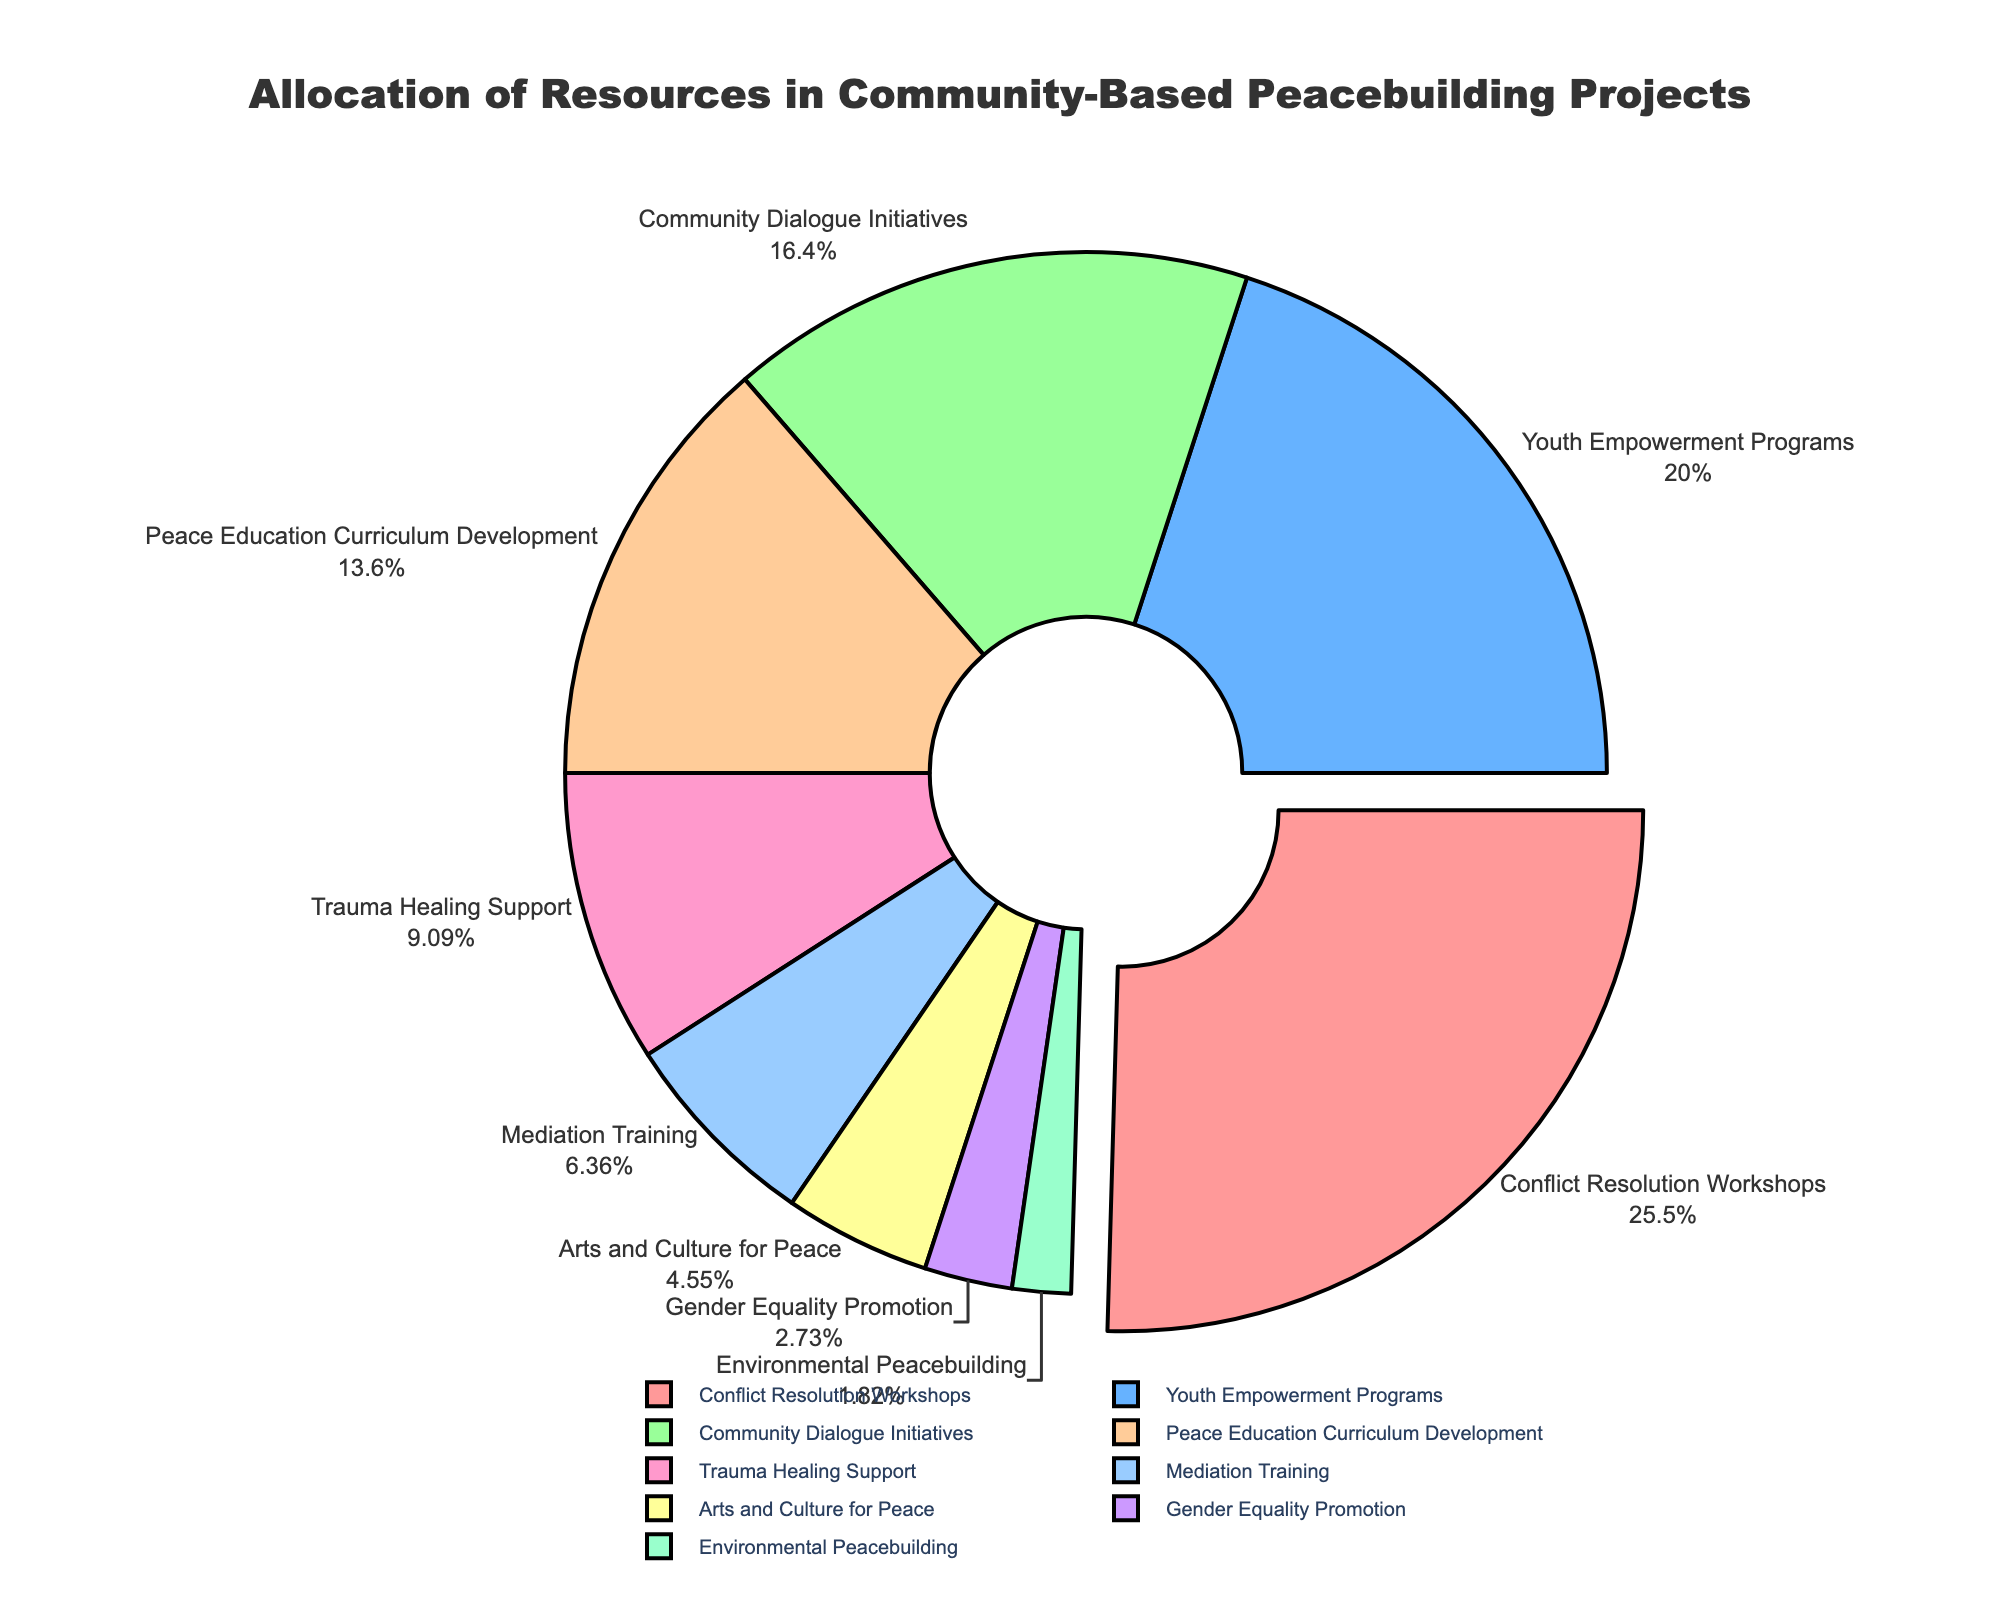Which category receives the highest allocation of resources? The largest portion of the pie chart, which is pulled out slightly, represents the category with the highest allocation of resources. This is "Conflict Resolution Workshops".
Answer: Conflict Resolution Workshops Which category has the smallest allocation of resources? The smallest slice of the pie chart is the one with "Environmental Peacebuilding".
Answer: Environmental Peacebuilding How much more percentage does 'Youth Empowerment Programs' receive compared to 'Mediation Training'? 'Youth Empowerment Programs' has 22% allocation, and 'Mediation Training' has 7%. The difference is calculated as 22% - 7%.
Answer: 15% What is the combined percentage of 'Community Dialogue Initiatives' and 'Peace Education Curriculum Development'? 'Community Dialogue Initiatives' has 18% and 'Peace Education Curriculum Development' has 15%. The combined percentage is 18% + 15%.
Answer: 33% Which has a higher allocation: 'Arts and Culture for Peace' or 'Trauma Healing Support'? Comparing the slices, 'Trauma Healing Support' with 10% is larger than 'Arts and Culture for Peace' with 5%.
Answer: Trauma Healing Support How much percentage of the resources is allocated to categories receiving more than 20% of the funding? The categories are 'Conflict Resolution Workshops' (28%) and 'Youth Empowerment Programs' (22%). Combined allocation is 28% + 22%.
Answer: 50% Is the allocation for 'Gender Equality Promotion' more or less than half of 'Community Dialogue Initiatives'? 'Community Dialogue Initiatives' has 18%, and half of this is 9%. 'Gender Equality Promotion' has 3%, which is less than 9%.
Answer: Less Which category is represented by the largest slice with the darkest color? The slice pulled out slightly and appears to have the darkest shade is the largest slice for 'Conflict Resolution Workshops'.
Answer: Conflict Resolution Workshops If the total allocation for 'Mediation Training' and 'Arts and Culture for Peace' is combined, how much would they represent together? 'Mediation Training' is 7% and 'Arts and Culture for Peace' is 5%. Their combined allocation is 7% + 5%.
Answer: 12% What is the difference in the percentage allocation between 'Peace Education Curriculum Development' and 'Youth Empowerment Programs'? 'Peace Education Curriculum Development' has 15%, and 'Youth Empowerment Programs' has 22%. The difference is calculated as 22% - 15%.
Answer: 7% 